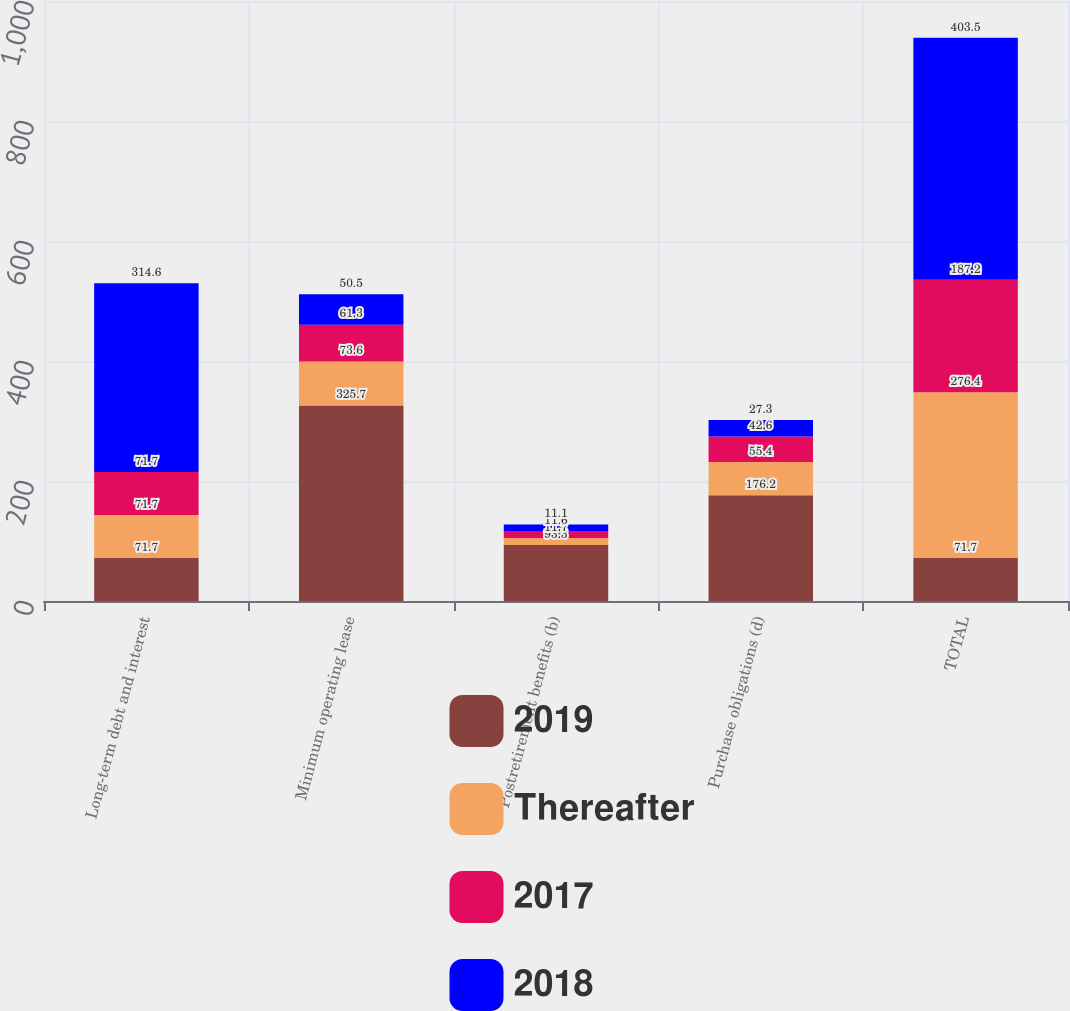Convert chart. <chart><loc_0><loc_0><loc_500><loc_500><stacked_bar_chart><ecel><fcel>Long-term debt and interest<fcel>Minimum operating lease<fcel>Postretirement benefits (b)<fcel>Purchase obligations (d)<fcel>TOTAL<nl><fcel>2019<fcel>71.7<fcel>325.7<fcel>93.3<fcel>176.2<fcel>71.7<nl><fcel>Thereafter<fcel>71.7<fcel>73.6<fcel>11.7<fcel>55.4<fcel>276.4<nl><fcel>2017<fcel>71.7<fcel>61.3<fcel>11.6<fcel>42.6<fcel>187.2<nl><fcel>2018<fcel>314.6<fcel>50.5<fcel>11.1<fcel>27.3<fcel>403.5<nl></chart> 